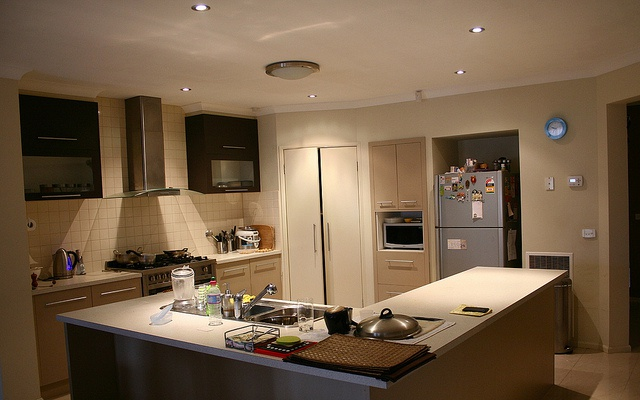Describe the objects in this image and their specific colors. I can see refrigerator in black, gray, and darkgray tones, oven in black, maroon, and gray tones, microwave in black and gray tones, sink in black, maroon, and gray tones, and cup in black, tan, and gray tones in this image. 